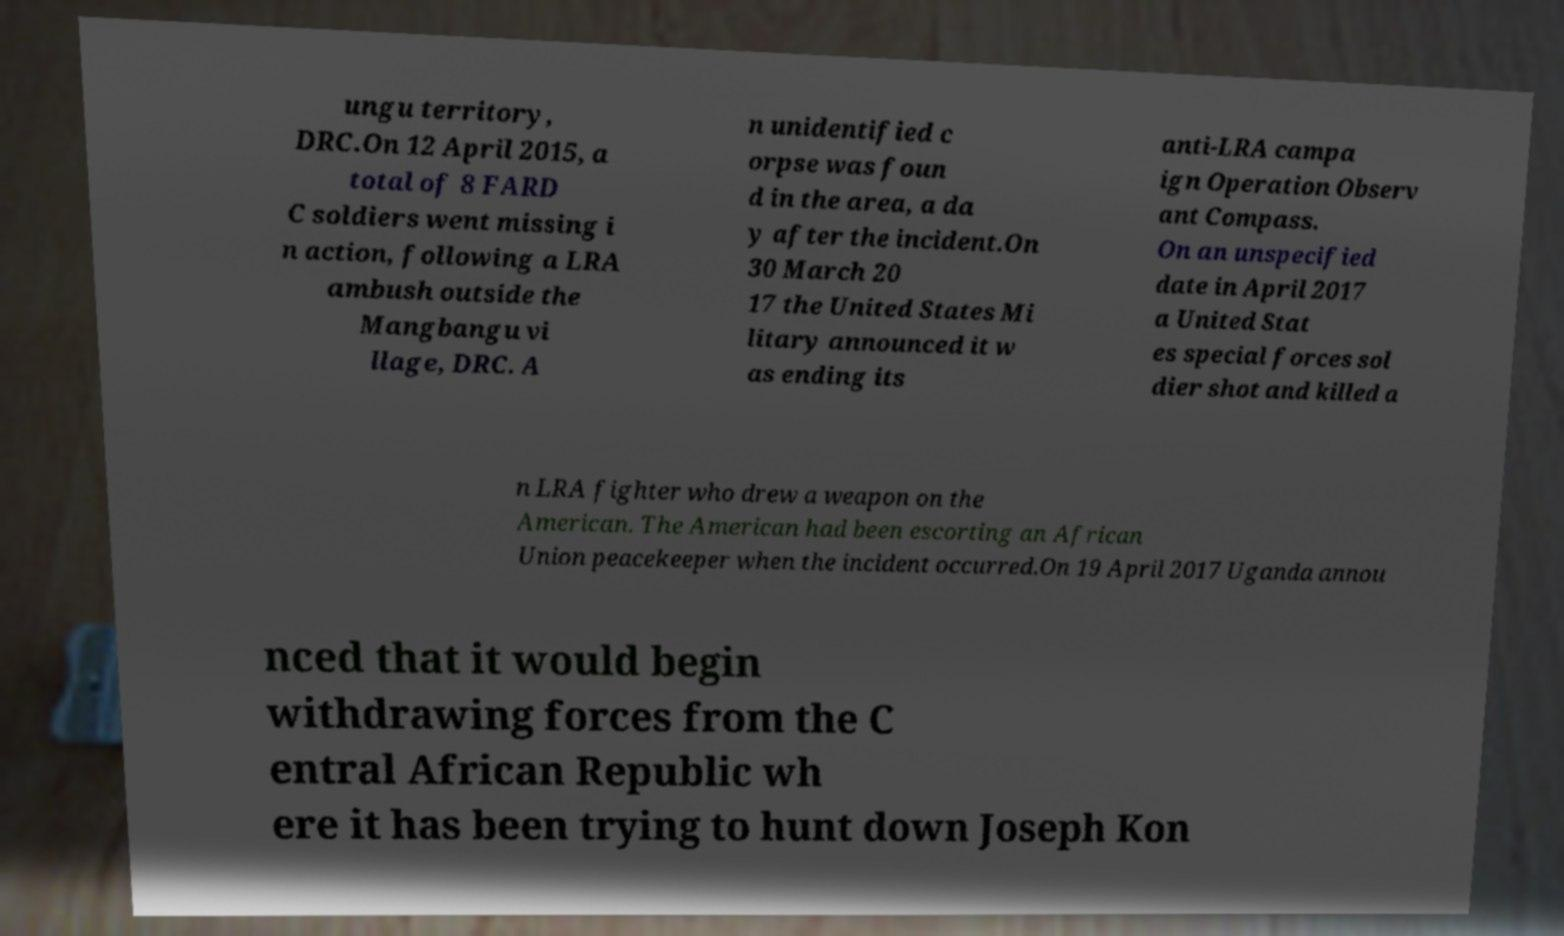Can you accurately transcribe the text from the provided image for me? ungu territory, DRC.On 12 April 2015, a total of 8 FARD C soldiers went missing i n action, following a LRA ambush outside the Mangbangu vi llage, DRC. A n unidentified c orpse was foun d in the area, a da y after the incident.On 30 March 20 17 the United States Mi litary announced it w as ending its anti-LRA campa ign Operation Observ ant Compass. On an unspecified date in April 2017 a United Stat es special forces sol dier shot and killed a n LRA fighter who drew a weapon on the American. The American had been escorting an African Union peacekeeper when the incident occurred.On 19 April 2017 Uganda annou nced that it would begin withdrawing forces from the C entral African Republic wh ere it has been trying to hunt down Joseph Kon 